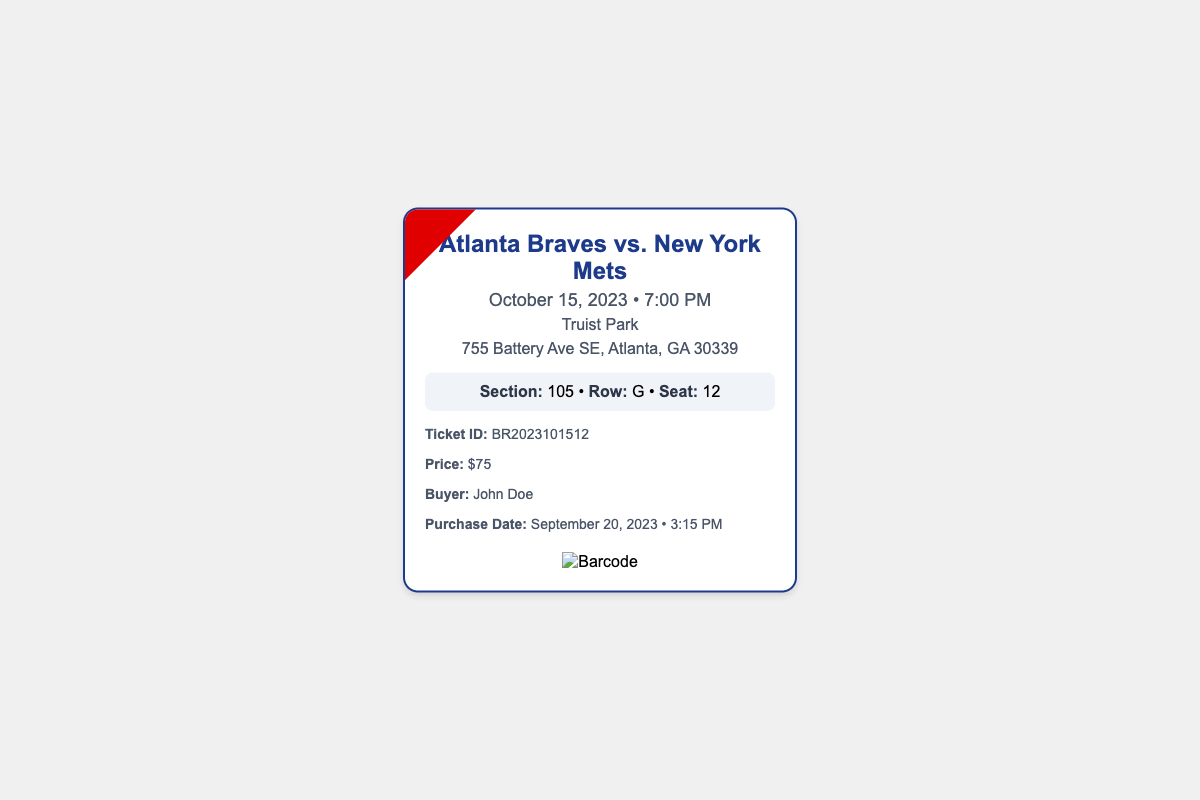What is the date of the match? The date of the match is prominently displayed in the document.
Answer: October 15, 2023 What time does the match start? The start time is clearly mentioned in the document.
Answer: 7:00 PM What is the venue for the match? The venue is specified as part of the match information.
Answer: Truist Park What is the section number of the seat? The section number is a specific detail listed in the seat information.
Answer: 105 Who is the buyer of the ticket? The buyer’s name is provided in the ticket details section.
Answer: John Doe What is the ticket ID? The ticket ID is explicitly stated in the document.
Answer: BR2023101512 How much did the ticket cost? The price of the ticket is mentioned clearly in the ticket details.
Answer: $75 In which row is the seat located? The row information is part of the seat details provided.
Answer: G How many seats are in the displayed seat info? The seat information gives a clear seating arrangement.
Answer: 1 seat 